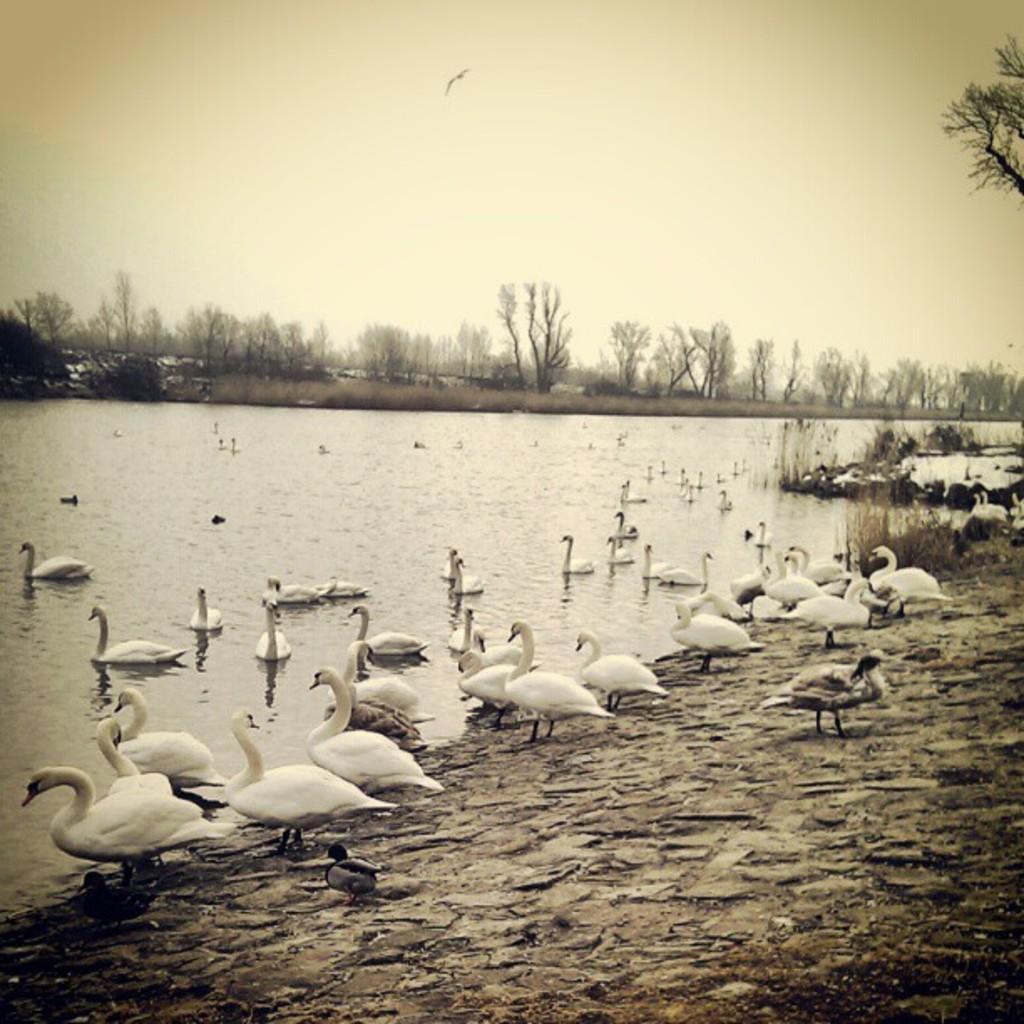Please provide a concise description of this image. This picture is a black and white image. In this image we can see one river, some swans in the water, few ducks in the water, two ducks on the ground, some swans on the ground, some rocks in the water, one bird flying in the sky, some trees, plants and grass on the ground. At the top there is the sky. 